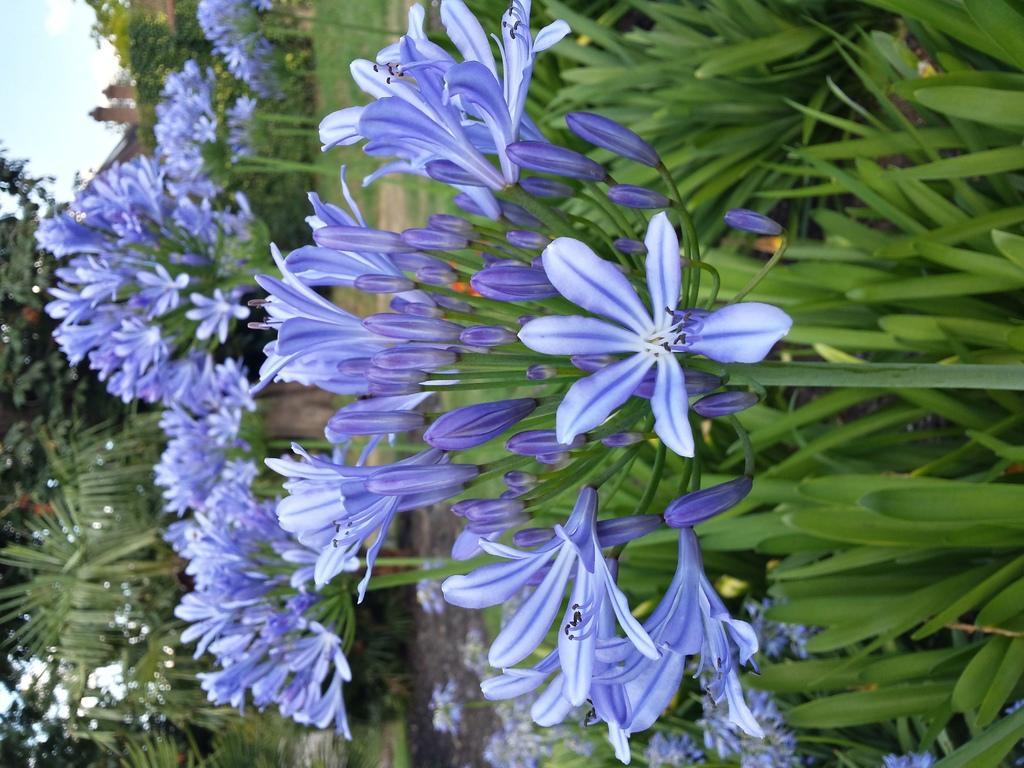How would you summarize this image in a sentence or two? In this image I can see in the middle there are flower plants. In the left hand side top, it is the sky, on the left side there are trees. 